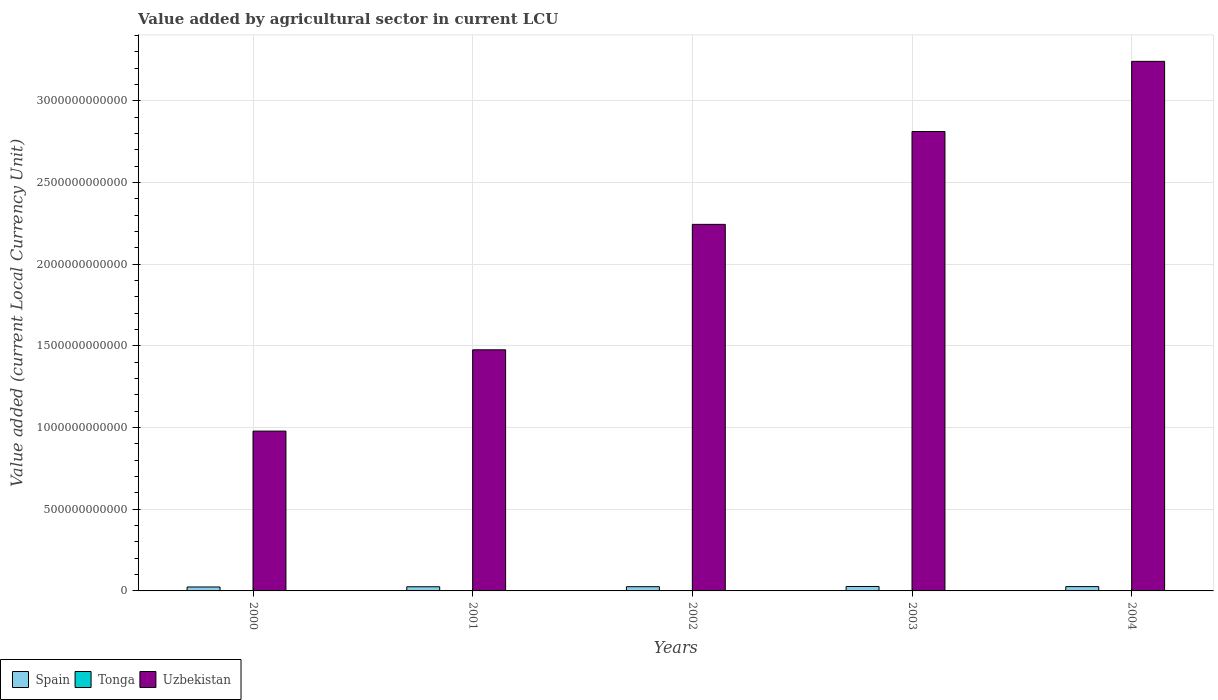How many different coloured bars are there?
Provide a succinct answer. 3. How many groups of bars are there?
Your answer should be very brief. 5. Are the number of bars on each tick of the X-axis equal?
Offer a very short reply. Yes. How many bars are there on the 5th tick from the left?
Your answer should be compact. 3. How many bars are there on the 1st tick from the right?
Keep it short and to the point. 3. What is the label of the 5th group of bars from the left?
Make the answer very short. 2004. In how many cases, is the number of bars for a given year not equal to the number of legend labels?
Your answer should be very brief. 0. What is the value added by agricultural sector in Tonga in 2001?
Your answer should be very brief. 6.51e+07. Across all years, what is the maximum value added by agricultural sector in Spain?
Offer a very short reply. 2.72e+1. Across all years, what is the minimum value added by agricultural sector in Tonga?
Ensure brevity in your answer.  6.51e+07. In which year was the value added by agricultural sector in Uzbekistan minimum?
Your answer should be very brief. 2000. What is the total value added by agricultural sector in Spain in the graph?
Make the answer very short. 1.29e+11. What is the difference between the value added by agricultural sector in Spain in 2002 and that in 2003?
Your answer should be compact. -1.28e+09. What is the difference between the value added by agricultural sector in Uzbekistan in 2002 and the value added by agricultural sector in Spain in 2004?
Offer a very short reply. 2.22e+12. What is the average value added by agricultural sector in Spain per year?
Your response must be concise. 2.58e+1. In the year 2003, what is the difference between the value added by agricultural sector in Uzbekistan and value added by agricultural sector in Tonga?
Your answer should be very brief. 2.81e+12. In how many years, is the value added by agricultural sector in Uzbekistan greater than 1700000000000 LCU?
Keep it short and to the point. 3. What is the ratio of the value added by agricultural sector in Spain in 2002 to that in 2004?
Your answer should be compact. 0.98. Is the value added by agricultural sector in Spain in 2000 less than that in 2003?
Your response must be concise. Yes. What is the difference between the highest and the second highest value added by agricultural sector in Tonga?
Give a very brief answer. 1.05e+07. What is the difference between the highest and the lowest value added by agricultural sector in Uzbekistan?
Give a very brief answer. 2.26e+12. In how many years, is the value added by agricultural sector in Spain greater than the average value added by agricultural sector in Spain taken over all years?
Your response must be concise. 3. Is the sum of the value added by agricultural sector in Spain in 2003 and 2004 greater than the maximum value added by agricultural sector in Uzbekistan across all years?
Provide a succinct answer. No. What does the 2nd bar from the left in 2003 represents?
Your response must be concise. Tonga. Is it the case that in every year, the sum of the value added by agricultural sector in Uzbekistan and value added by agricultural sector in Spain is greater than the value added by agricultural sector in Tonga?
Give a very brief answer. Yes. What is the difference between two consecutive major ticks on the Y-axis?
Your response must be concise. 5.00e+11. Are the values on the major ticks of Y-axis written in scientific E-notation?
Your response must be concise. No. Does the graph contain any zero values?
Offer a terse response. No. Does the graph contain grids?
Make the answer very short. Yes. How many legend labels are there?
Make the answer very short. 3. What is the title of the graph?
Keep it short and to the point. Value added by agricultural sector in current LCU. What is the label or title of the Y-axis?
Offer a very short reply. Value added (current Local Currency Unit). What is the Value added (current Local Currency Unit) in Spain in 2000?
Ensure brevity in your answer.  2.42e+1. What is the Value added (current Local Currency Unit) in Tonga in 2000?
Ensure brevity in your answer.  6.62e+07. What is the Value added (current Local Currency Unit) in Uzbekistan in 2000?
Your answer should be very brief. 9.78e+11. What is the Value added (current Local Currency Unit) of Spain in 2001?
Provide a succinct answer. 2.55e+1. What is the Value added (current Local Currency Unit) in Tonga in 2001?
Provide a succinct answer. 6.51e+07. What is the Value added (current Local Currency Unit) in Uzbekistan in 2001?
Offer a very short reply. 1.48e+12. What is the Value added (current Local Currency Unit) in Spain in 2002?
Your response must be concise. 2.59e+1. What is the Value added (current Local Currency Unit) of Tonga in 2002?
Your answer should be very brief. 7.26e+07. What is the Value added (current Local Currency Unit) in Uzbekistan in 2002?
Offer a very short reply. 2.24e+12. What is the Value added (current Local Currency Unit) of Spain in 2003?
Offer a terse response. 2.72e+1. What is the Value added (current Local Currency Unit) of Tonga in 2003?
Give a very brief answer. 8.54e+07. What is the Value added (current Local Currency Unit) in Uzbekistan in 2003?
Offer a very short reply. 2.81e+12. What is the Value added (current Local Currency Unit) of Spain in 2004?
Make the answer very short. 2.65e+1. What is the Value added (current Local Currency Unit) in Tonga in 2004?
Keep it short and to the point. 9.59e+07. What is the Value added (current Local Currency Unit) of Uzbekistan in 2004?
Provide a succinct answer. 3.24e+12. Across all years, what is the maximum Value added (current Local Currency Unit) of Spain?
Your answer should be very brief. 2.72e+1. Across all years, what is the maximum Value added (current Local Currency Unit) in Tonga?
Provide a short and direct response. 9.59e+07. Across all years, what is the maximum Value added (current Local Currency Unit) of Uzbekistan?
Your answer should be compact. 3.24e+12. Across all years, what is the minimum Value added (current Local Currency Unit) in Spain?
Ensure brevity in your answer.  2.42e+1. Across all years, what is the minimum Value added (current Local Currency Unit) of Tonga?
Your answer should be compact. 6.51e+07. Across all years, what is the minimum Value added (current Local Currency Unit) of Uzbekistan?
Offer a terse response. 9.78e+11. What is the total Value added (current Local Currency Unit) in Spain in the graph?
Keep it short and to the point. 1.29e+11. What is the total Value added (current Local Currency Unit) in Tonga in the graph?
Give a very brief answer. 3.85e+08. What is the total Value added (current Local Currency Unit) of Uzbekistan in the graph?
Your answer should be very brief. 1.08e+13. What is the difference between the Value added (current Local Currency Unit) of Spain in 2000 and that in 2001?
Offer a very short reply. -1.37e+09. What is the difference between the Value added (current Local Currency Unit) of Tonga in 2000 and that in 2001?
Give a very brief answer. 1.06e+06. What is the difference between the Value added (current Local Currency Unit) in Uzbekistan in 2000 and that in 2001?
Your answer should be very brief. -4.98e+11. What is the difference between the Value added (current Local Currency Unit) in Spain in 2000 and that in 2002?
Give a very brief answer. -1.73e+09. What is the difference between the Value added (current Local Currency Unit) in Tonga in 2000 and that in 2002?
Offer a terse response. -6.38e+06. What is the difference between the Value added (current Local Currency Unit) in Uzbekistan in 2000 and that in 2002?
Provide a short and direct response. -1.27e+12. What is the difference between the Value added (current Local Currency Unit) of Spain in 2000 and that in 2003?
Offer a very short reply. -3.01e+09. What is the difference between the Value added (current Local Currency Unit) in Tonga in 2000 and that in 2003?
Provide a short and direct response. -1.93e+07. What is the difference between the Value added (current Local Currency Unit) in Uzbekistan in 2000 and that in 2003?
Offer a terse response. -1.83e+12. What is the difference between the Value added (current Local Currency Unit) of Spain in 2000 and that in 2004?
Offer a very short reply. -2.32e+09. What is the difference between the Value added (current Local Currency Unit) in Tonga in 2000 and that in 2004?
Your answer should be compact. -2.97e+07. What is the difference between the Value added (current Local Currency Unit) in Uzbekistan in 2000 and that in 2004?
Make the answer very short. -2.26e+12. What is the difference between the Value added (current Local Currency Unit) of Spain in 2001 and that in 2002?
Make the answer very short. -3.58e+08. What is the difference between the Value added (current Local Currency Unit) in Tonga in 2001 and that in 2002?
Ensure brevity in your answer.  -7.43e+06. What is the difference between the Value added (current Local Currency Unit) of Uzbekistan in 2001 and that in 2002?
Your answer should be compact. -7.68e+11. What is the difference between the Value added (current Local Currency Unit) in Spain in 2001 and that in 2003?
Keep it short and to the point. -1.64e+09. What is the difference between the Value added (current Local Currency Unit) of Tonga in 2001 and that in 2003?
Ensure brevity in your answer.  -2.03e+07. What is the difference between the Value added (current Local Currency Unit) in Uzbekistan in 2001 and that in 2003?
Make the answer very short. -1.34e+12. What is the difference between the Value added (current Local Currency Unit) of Spain in 2001 and that in 2004?
Offer a very short reply. -9.45e+08. What is the difference between the Value added (current Local Currency Unit) in Tonga in 2001 and that in 2004?
Give a very brief answer. -3.08e+07. What is the difference between the Value added (current Local Currency Unit) in Uzbekistan in 2001 and that in 2004?
Keep it short and to the point. -1.77e+12. What is the difference between the Value added (current Local Currency Unit) of Spain in 2002 and that in 2003?
Provide a succinct answer. -1.28e+09. What is the difference between the Value added (current Local Currency Unit) of Tonga in 2002 and that in 2003?
Make the answer very short. -1.29e+07. What is the difference between the Value added (current Local Currency Unit) in Uzbekistan in 2002 and that in 2003?
Ensure brevity in your answer.  -5.68e+11. What is the difference between the Value added (current Local Currency Unit) of Spain in 2002 and that in 2004?
Offer a terse response. -5.87e+08. What is the difference between the Value added (current Local Currency Unit) of Tonga in 2002 and that in 2004?
Provide a succinct answer. -2.34e+07. What is the difference between the Value added (current Local Currency Unit) of Uzbekistan in 2002 and that in 2004?
Keep it short and to the point. -9.98e+11. What is the difference between the Value added (current Local Currency Unit) in Spain in 2003 and that in 2004?
Offer a very short reply. 6.93e+08. What is the difference between the Value added (current Local Currency Unit) in Tonga in 2003 and that in 2004?
Your response must be concise. -1.05e+07. What is the difference between the Value added (current Local Currency Unit) in Uzbekistan in 2003 and that in 2004?
Give a very brief answer. -4.30e+11. What is the difference between the Value added (current Local Currency Unit) of Spain in 2000 and the Value added (current Local Currency Unit) of Tonga in 2001?
Provide a succinct answer. 2.41e+1. What is the difference between the Value added (current Local Currency Unit) in Spain in 2000 and the Value added (current Local Currency Unit) in Uzbekistan in 2001?
Provide a succinct answer. -1.45e+12. What is the difference between the Value added (current Local Currency Unit) of Tonga in 2000 and the Value added (current Local Currency Unit) of Uzbekistan in 2001?
Your answer should be very brief. -1.48e+12. What is the difference between the Value added (current Local Currency Unit) in Spain in 2000 and the Value added (current Local Currency Unit) in Tonga in 2002?
Provide a succinct answer. 2.41e+1. What is the difference between the Value added (current Local Currency Unit) of Spain in 2000 and the Value added (current Local Currency Unit) of Uzbekistan in 2002?
Offer a terse response. -2.22e+12. What is the difference between the Value added (current Local Currency Unit) in Tonga in 2000 and the Value added (current Local Currency Unit) in Uzbekistan in 2002?
Provide a succinct answer. -2.24e+12. What is the difference between the Value added (current Local Currency Unit) in Spain in 2000 and the Value added (current Local Currency Unit) in Tonga in 2003?
Ensure brevity in your answer.  2.41e+1. What is the difference between the Value added (current Local Currency Unit) of Spain in 2000 and the Value added (current Local Currency Unit) of Uzbekistan in 2003?
Your answer should be compact. -2.79e+12. What is the difference between the Value added (current Local Currency Unit) in Tonga in 2000 and the Value added (current Local Currency Unit) in Uzbekistan in 2003?
Offer a terse response. -2.81e+12. What is the difference between the Value added (current Local Currency Unit) of Spain in 2000 and the Value added (current Local Currency Unit) of Tonga in 2004?
Give a very brief answer. 2.41e+1. What is the difference between the Value added (current Local Currency Unit) of Spain in 2000 and the Value added (current Local Currency Unit) of Uzbekistan in 2004?
Provide a short and direct response. -3.22e+12. What is the difference between the Value added (current Local Currency Unit) of Tonga in 2000 and the Value added (current Local Currency Unit) of Uzbekistan in 2004?
Provide a short and direct response. -3.24e+12. What is the difference between the Value added (current Local Currency Unit) of Spain in 2001 and the Value added (current Local Currency Unit) of Tonga in 2002?
Your answer should be very brief. 2.55e+1. What is the difference between the Value added (current Local Currency Unit) of Spain in 2001 and the Value added (current Local Currency Unit) of Uzbekistan in 2002?
Keep it short and to the point. -2.22e+12. What is the difference between the Value added (current Local Currency Unit) of Tonga in 2001 and the Value added (current Local Currency Unit) of Uzbekistan in 2002?
Provide a succinct answer. -2.24e+12. What is the difference between the Value added (current Local Currency Unit) in Spain in 2001 and the Value added (current Local Currency Unit) in Tonga in 2003?
Make the answer very short. 2.54e+1. What is the difference between the Value added (current Local Currency Unit) of Spain in 2001 and the Value added (current Local Currency Unit) of Uzbekistan in 2003?
Offer a very short reply. -2.79e+12. What is the difference between the Value added (current Local Currency Unit) of Tonga in 2001 and the Value added (current Local Currency Unit) of Uzbekistan in 2003?
Ensure brevity in your answer.  -2.81e+12. What is the difference between the Value added (current Local Currency Unit) in Spain in 2001 and the Value added (current Local Currency Unit) in Tonga in 2004?
Provide a succinct answer. 2.54e+1. What is the difference between the Value added (current Local Currency Unit) in Spain in 2001 and the Value added (current Local Currency Unit) in Uzbekistan in 2004?
Your answer should be compact. -3.22e+12. What is the difference between the Value added (current Local Currency Unit) of Tonga in 2001 and the Value added (current Local Currency Unit) of Uzbekistan in 2004?
Give a very brief answer. -3.24e+12. What is the difference between the Value added (current Local Currency Unit) of Spain in 2002 and the Value added (current Local Currency Unit) of Tonga in 2003?
Offer a terse response. 2.58e+1. What is the difference between the Value added (current Local Currency Unit) of Spain in 2002 and the Value added (current Local Currency Unit) of Uzbekistan in 2003?
Ensure brevity in your answer.  -2.79e+12. What is the difference between the Value added (current Local Currency Unit) in Tonga in 2002 and the Value added (current Local Currency Unit) in Uzbekistan in 2003?
Provide a short and direct response. -2.81e+12. What is the difference between the Value added (current Local Currency Unit) of Spain in 2002 and the Value added (current Local Currency Unit) of Tonga in 2004?
Provide a succinct answer. 2.58e+1. What is the difference between the Value added (current Local Currency Unit) of Spain in 2002 and the Value added (current Local Currency Unit) of Uzbekistan in 2004?
Offer a very short reply. -3.22e+12. What is the difference between the Value added (current Local Currency Unit) of Tonga in 2002 and the Value added (current Local Currency Unit) of Uzbekistan in 2004?
Your response must be concise. -3.24e+12. What is the difference between the Value added (current Local Currency Unit) in Spain in 2003 and the Value added (current Local Currency Unit) in Tonga in 2004?
Your response must be concise. 2.71e+1. What is the difference between the Value added (current Local Currency Unit) in Spain in 2003 and the Value added (current Local Currency Unit) in Uzbekistan in 2004?
Offer a very short reply. -3.22e+12. What is the difference between the Value added (current Local Currency Unit) in Tonga in 2003 and the Value added (current Local Currency Unit) in Uzbekistan in 2004?
Provide a short and direct response. -3.24e+12. What is the average Value added (current Local Currency Unit) of Spain per year?
Your answer should be very brief. 2.58e+1. What is the average Value added (current Local Currency Unit) of Tonga per year?
Offer a terse response. 7.70e+07. What is the average Value added (current Local Currency Unit) of Uzbekistan per year?
Your answer should be compact. 2.15e+12. In the year 2000, what is the difference between the Value added (current Local Currency Unit) of Spain and Value added (current Local Currency Unit) of Tonga?
Keep it short and to the point. 2.41e+1. In the year 2000, what is the difference between the Value added (current Local Currency Unit) of Spain and Value added (current Local Currency Unit) of Uzbekistan?
Provide a short and direct response. -9.54e+11. In the year 2000, what is the difference between the Value added (current Local Currency Unit) in Tonga and Value added (current Local Currency Unit) in Uzbekistan?
Provide a short and direct response. -9.78e+11. In the year 2001, what is the difference between the Value added (current Local Currency Unit) in Spain and Value added (current Local Currency Unit) in Tonga?
Offer a very short reply. 2.55e+1. In the year 2001, what is the difference between the Value added (current Local Currency Unit) of Spain and Value added (current Local Currency Unit) of Uzbekistan?
Your response must be concise. -1.45e+12. In the year 2001, what is the difference between the Value added (current Local Currency Unit) of Tonga and Value added (current Local Currency Unit) of Uzbekistan?
Ensure brevity in your answer.  -1.48e+12. In the year 2002, what is the difference between the Value added (current Local Currency Unit) of Spain and Value added (current Local Currency Unit) of Tonga?
Provide a succinct answer. 2.58e+1. In the year 2002, what is the difference between the Value added (current Local Currency Unit) of Spain and Value added (current Local Currency Unit) of Uzbekistan?
Your answer should be very brief. -2.22e+12. In the year 2002, what is the difference between the Value added (current Local Currency Unit) of Tonga and Value added (current Local Currency Unit) of Uzbekistan?
Offer a very short reply. -2.24e+12. In the year 2003, what is the difference between the Value added (current Local Currency Unit) of Spain and Value added (current Local Currency Unit) of Tonga?
Provide a succinct answer. 2.71e+1. In the year 2003, what is the difference between the Value added (current Local Currency Unit) of Spain and Value added (current Local Currency Unit) of Uzbekistan?
Make the answer very short. -2.79e+12. In the year 2003, what is the difference between the Value added (current Local Currency Unit) in Tonga and Value added (current Local Currency Unit) in Uzbekistan?
Keep it short and to the point. -2.81e+12. In the year 2004, what is the difference between the Value added (current Local Currency Unit) of Spain and Value added (current Local Currency Unit) of Tonga?
Ensure brevity in your answer.  2.64e+1. In the year 2004, what is the difference between the Value added (current Local Currency Unit) in Spain and Value added (current Local Currency Unit) in Uzbekistan?
Offer a very short reply. -3.22e+12. In the year 2004, what is the difference between the Value added (current Local Currency Unit) in Tonga and Value added (current Local Currency Unit) in Uzbekistan?
Give a very brief answer. -3.24e+12. What is the ratio of the Value added (current Local Currency Unit) in Spain in 2000 to that in 2001?
Provide a short and direct response. 0.95. What is the ratio of the Value added (current Local Currency Unit) in Tonga in 2000 to that in 2001?
Your answer should be very brief. 1.02. What is the ratio of the Value added (current Local Currency Unit) of Uzbekistan in 2000 to that in 2001?
Provide a succinct answer. 0.66. What is the ratio of the Value added (current Local Currency Unit) of Spain in 2000 to that in 2002?
Offer a terse response. 0.93. What is the ratio of the Value added (current Local Currency Unit) in Tonga in 2000 to that in 2002?
Ensure brevity in your answer.  0.91. What is the ratio of the Value added (current Local Currency Unit) in Uzbekistan in 2000 to that in 2002?
Provide a short and direct response. 0.44. What is the ratio of the Value added (current Local Currency Unit) in Spain in 2000 to that in 2003?
Provide a short and direct response. 0.89. What is the ratio of the Value added (current Local Currency Unit) in Tonga in 2000 to that in 2003?
Give a very brief answer. 0.77. What is the ratio of the Value added (current Local Currency Unit) of Uzbekistan in 2000 to that in 2003?
Offer a terse response. 0.35. What is the ratio of the Value added (current Local Currency Unit) in Spain in 2000 to that in 2004?
Give a very brief answer. 0.91. What is the ratio of the Value added (current Local Currency Unit) in Tonga in 2000 to that in 2004?
Your response must be concise. 0.69. What is the ratio of the Value added (current Local Currency Unit) in Uzbekistan in 2000 to that in 2004?
Offer a very short reply. 0.3. What is the ratio of the Value added (current Local Currency Unit) in Spain in 2001 to that in 2002?
Your answer should be compact. 0.99. What is the ratio of the Value added (current Local Currency Unit) of Tonga in 2001 to that in 2002?
Your answer should be very brief. 0.9. What is the ratio of the Value added (current Local Currency Unit) in Uzbekistan in 2001 to that in 2002?
Ensure brevity in your answer.  0.66. What is the ratio of the Value added (current Local Currency Unit) of Spain in 2001 to that in 2003?
Give a very brief answer. 0.94. What is the ratio of the Value added (current Local Currency Unit) in Tonga in 2001 to that in 2003?
Offer a very short reply. 0.76. What is the ratio of the Value added (current Local Currency Unit) in Uzbekistan in 2001 to that in 2003?
Give a very brief answer. 0.52. What is the ratio of the Value added (current Local Currency Unit) in Tonga in 2001 to that in 2004?
Give a very brief answer. 0.68. What is the ratio of the Value added (current Local Currency Unit) of Uzbekistan in 2001 to that in 2004?
Provide a short and direct response. 0.46. What is the ratio of the Value added (current Local Currency Unit) of Spain in 2002 to that in 2003?
Provide a succinct answer. 0.95. What is the ratio of the Value added (current Local Currency Unit) in Tonga in 2002 to that in 2003?
Provide a succinct answer. 0.85. What is the ratio of the Value added (current Local Currency Unit) of Uzbekistan in 2002 to that in 2003?
Make the answer very short. 0.8. What is the ratio of the Value added (current Local Currency Unit) of Spain in 2002 to that in 2004?
Your answer should be very brief. 0.98. What is the ratio of the Value added (current Local Currency Unit) of Tonga in 2002 to that in 2004?
Your response must be concise. 0.76. What is the ratio of the Value added (current Local Currency Unit) of Uzbekistan in 2002 to that in 2004?
Your response must be concise. 0.69. What is the ratio of the Value added (current Local Currency Unit) in Spain in 2003 to that in 2004?
Ensure brevity in your answer.  1.03. What is the ratio of the Value added (current Local Currency Unit) in Tonga in 2003 to that in 2004?
Your response must be concise. 0.89. What is the ratio of the Value added (current Local Currency Unit) of Uzbekistan in 2003 to that in 2004?
Your response must be concise. 0.87. What is the difference between the highest and the second highest Value added (current Local Currency Unit) in Spain?
Provide a short and direct response. 6.93e+08. What is the difference between the highest and the second highest Value added (current Local Currency Unit) of Tonga?
Your answer should be very brief. 1.05e+07. What is the difference between the highest and the second highest Value added (current Local Currency Unit) in Uzbekistan?
Provide a succinct answer. 4.30e+11. What is the difference between the highest and the lowest Value added (current Local Currency Unit) of Spain?
Provide a short and direct response. 3.01e+09. What is the difference between the highest and the lowest Value added (current Local Currency Unit) of Tonga?
Offer a very short reply. 3.08e+07. What is the difference between the highest and the lowest Value added (current Local Currency Unit) in Uzbekistan?
Provide a succinct answer. 2.26e+12. 